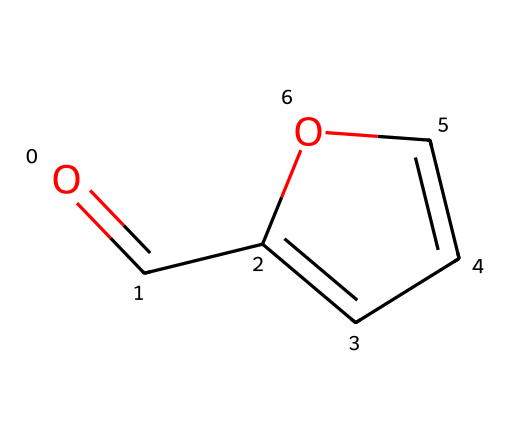How many carbon atoms are in furfural? The SMILES representation shows "O=CC1=CC=CO1". Counting the 'C' letters indicates a total of 5 carbon atoms.
Answer: 5 What type of functional group does furfural contain? The structure indicates a carbonyl group (C=O) at the end of the carbon chain, characteristic of aldehydes.
Answer: aldehyde How many double bonds are present in the structure of furfural? Investigating the SMILES, there are two double bonds indicated by the "=" symbols in the carbon framework.
Answer: 2 What is the total number of oxygen atoms in furfural? In the SMILES, there is one 'O' indicating the presence of a single oxygen atom in the molecule.
Answer: 1 Can you identify any rings in the structure of furfural? The "C1=CC=CO1" portion indicates a cyclic structure (a ring) as noted by the numbering of the carbon atoms.
Answer: yes What is the molecular formula of furfural based on its structure? From the structure, there are 5 carbon atoms, 4 hydrogen atoms, and 1 oxygen atom, resulting in the molecular formula C5H4O.
Answer: C5H4O 